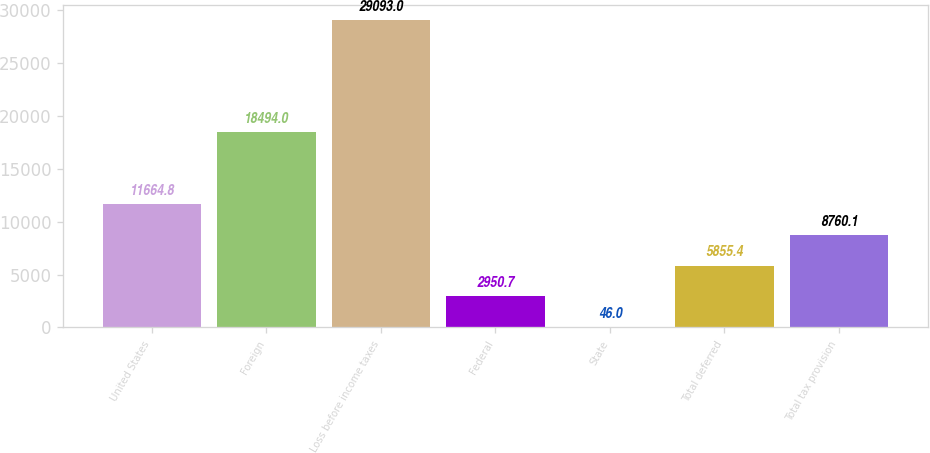Convert chart. <chart><loc_0><loc_0><loc_500><loc_500><bar_chart><fcel>United States<fcel>Foreign<fcel>Loss before income taxes<fcel>Federal<fcel>State<fcel>Total deferred<fcel>Total tax provision<nl><fcel>11664.8<fcel>18494<fcel>29093<fcel>2950.7<fcel>46<fcel>5855.4<fcel>8760.1<nl></chart> 